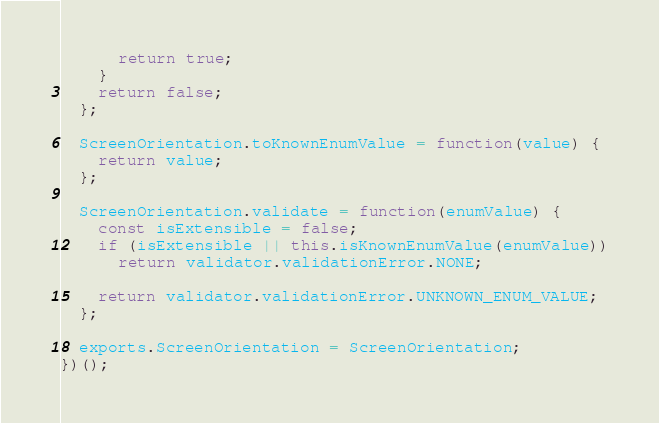Convert code to text. <code><loc_0><loc_0><loc_500><loc_500><_JavaScript_>      return true;
    }
    return false;
  };

  ScreenOrientation.toKnownEnumValue = function(value) {
    return value;
  };

  ScreenOrientation.validate = function(enumValue) {
    const isExtensible = false;
    if (isExtensible || this.isKnownEnumValue(enumValue))
      return validator.validationError.NONE;

    return validator.validationError.UNKNOWN_ENUM_VALUE;
  };

  exports.ScreenOrientation = ScreenOrientation;
})();</code> 